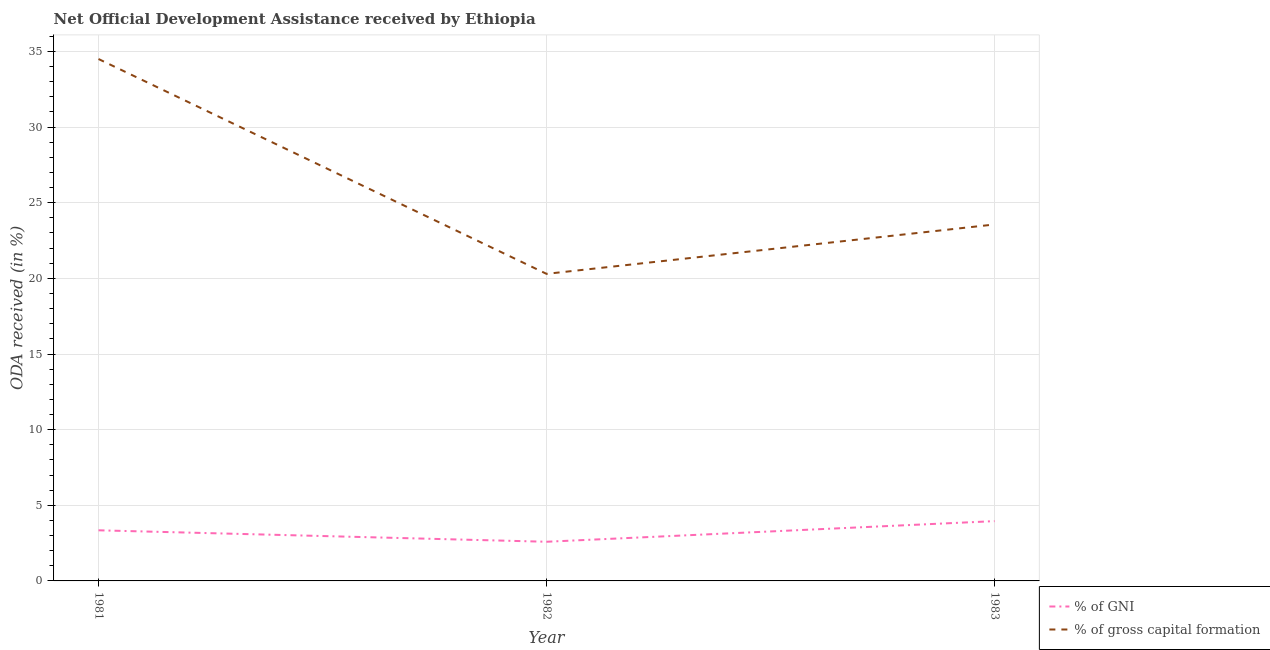Is the number of lines equal to the number of legend labels?
Your answer should be compact. Yes. What is the oda received as percentage of gni in 1981?
Your answer should be very brief. 3.35. Across all years, what is the maximum oda received as percentage of gross capital formation?
Ensure brevity in your answer.  34.5. Across all years, what is the minimum oda received as percentage of gni?
Provide a short and direct response. 2.59. What is the total oda received as percentage of gross capital formation in the graph?
Offer a very short reply. 78.36. What is the difference between the oda received as percentage of gross capital formation in 1981 and that in 1982?
Your answer should be very brief. 14.2. What is the difference between the oda received as percentage of gross capital formation in 1981 and the oda received as percentage of gni in 1982?
Your answer should be very brief. 31.91. What is the average oda received as percentage of gross capital formation per year?
Your response must be concise. 26.12. In the year 1981, what is the difference between the oda received as percentage of gross capital formation and oda received as percentage of gni?
Provide a succinct answer. 31.15. In how many years, is the oda received as percentage of gross capital formation greater than 14 %?
Ensure brevity in your answer.  3. What is the ratio of the oda received as percentage of gross capital formation in 1981 to that in 1983?
Provide a succinct answer. 1.46. What is the difference between the highest and the second highest oda received as percentage of gross capital formation?
Your answer should be compact. 10.94. What is the difference between the highest and the lowest oda received as percentage of gni?
Offer a very short reply. 1.36. Does the oda received as percentage of gni monotonically increase over the years?
Your answer should be very brief. No. How many years are there in the graph?
Your answer should be compact. 3. What is the difference between two consecutive major ticks on the Y-axis?
Offer a terse response. 5. Are the values on the major ticks of Y-axis written in scientific E-notation?
Keep it short and to the point. No. Does the graph contain grids?
Keep it short and to the point. Yes. Where does the legend appear in the graph?
Offer a terse response. Bottom right. How many legend labels are there?
Provide a succinct answer. 2. What is the title of the graph?
Make the answer very short. Net Official Development Assistance received by Ethiopia. Does "Foreign liabilities" appear as one of the legend labels in the graph?
Provide a short and direct response. No. What is the label or title of the Y-axis?
Provide a succinct answer. ODA received (in %). What is the ODA received (in %) in % of GNI in 1981?
Your answer should be compact. 3.35. What is the ODA received (in %) in % of gross capital formation in 1981?
Give a very brief answer. 34.5. What is the ODA received (in %) in % of GNI in 1982?
Make the answer very short. 2.59. What is the ODA received (in %) of % of gross capital formation in 1982?
Offer a terse response. 20.3. What is the ODA received (in %) in % of GNI in 1983?
Offer a very short reply. 3.95. What is the ODA received (in %) of % of gross capital formation in 1983?
Give a very brief answer. 23.56. Across all years, what is the maximum ODA received (in %) in % of GNI?
Provide a short and direct response. 3.95. Across all years, what is the maximum ODA received (in %) in % of gross capital formation?
Make the answer very short. 34.5. Across all years, what is the minimum ODA received (in %) in % of GNI?
Offer a terse response. 2.59. Across all years, what is the minimum ODA received (in %) of % of gross capital formation?
Ensure brevity in your answer.  20.3. What is the total ODA received (in %) of % of GNI in the graph?
Offer a very short reply. 9.89. What is the total ODA received (in %) of % of gross capital formation in the graph?
Make the answer very short. 78.36. What is the difference between the ODA received (in %) in % of GNI in 1981 and that in 1982?
Your answer should be very brief. 0.76. What is the difference between the ODA received (in %) of % of gross capital formation in 1981 and that in 1982?
Provide a succinct answer. 14.2. What is the difference between the ODA received (in %) of % of GNI in 1981 and that in 1983?
Offer a very short reply. -0.61. What is the difference between the ODA received (in %) of % of gross capital formation in 1981 and that in 1983?
Your answer should be compact. 10.94. What is the difference between the ODA received (in %) of % of GNI in 1982 and that in 1983?
Provide a succinct answer. -1.36. What is the difference between the ODA received (in %) in % of gross capital formation in 1982 and that in 1983?
Your answer should be compact. -3.26. What is the difference between the ODA received (in %) of % of GNI in 1981 and the ODA received (in %) of % of gross capital formation in 1982?
Ensure brevity in your answer.  -16.95. What is the difference between the ODA received (in %) of % of GNI in 1981 and the ODA received (in %) of % of gross capital formation in 1983?
Provide a succinct answer. -20.22. What is the difference between the ODA received (in %) in % of GNI in 1982 and the ODA received (in %) in % of gross capital formation in 1983?
Ensure brevity in your answer.  -20.97. What is the average ODA received (in %) in % of GNI per year?
Ensure brevity in your answer.  3.3. What is the average ODA received (in %) in % of gross capital formation per year?
Your answer should be very brief. 26.12. In the year 1981, what is the difference between the ODA received (in %) in % of GNI and ODA received (in %) in % of gross capital formation?
Your answer should be compact. -31.15. In the year 1982, what is the difference between the ODA received (in %) in % of GNI and ODA received (in %) in % of gross capital formation?
Keep it short and to the point. -17.71. In the year 1983, what is the difference between the ODA received (in %) of % of GNI and ODA received (in %) of % of gross capital formation?
Your response must be concise. -19.61. What is the ratio of the ODA received (in %) of % of GNI in 1981 to that in 1982?
Make the answer very short. 1.29. What is the ratio of the ODA received (in %) in % of gross capital formation in 1981 to that in 1982?
Your answer should be compact. 1.7. What is the ratio of the ODA received (in %) of % of GNI in 1981 to that in 1983?
Your answer should be compact. 0.85. What is the ratio of the ODA received (in %) in % of gross capital formation in 1981 to that in 1983?
Your response must be concise. 1.46. What is the ratio of the ODA received (in %) in % of GNI in 1982 to that in 1983?
Offer a very short reply. 0.66. What is the ratio of the ODA received (in %) in % of gross capital formation in 1982 to that in 1983?
Keep it short and to the point. 0.86. What is the difference between the highest and the second highest ODA received (in %) in % of GNI?
Provide a short and direct response. 0.61. What is the difference between the highest and the second highest ODA received (in %) of % of gross capital formation?
Give a very brief answer. 10.94. What is the difference between the highest and the lowest ODA received (in %) of % of GNI?
Provide a succinct answer. 1.36. What is the difference between the highest and the lowest ODA received (in %) in % of gross capital formation?
Keep it short and to the point. 14.2. 